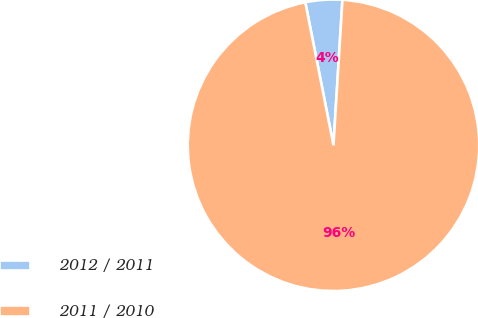Convert chart to OTSL. <chart><loc_0><loc_0><loc_500><loc_500><pie_chart><fcel>2012 / 2011<fcel>2011 / 2010<nl><fcel>4.08%<fcel>95.92%<nl></chart> 